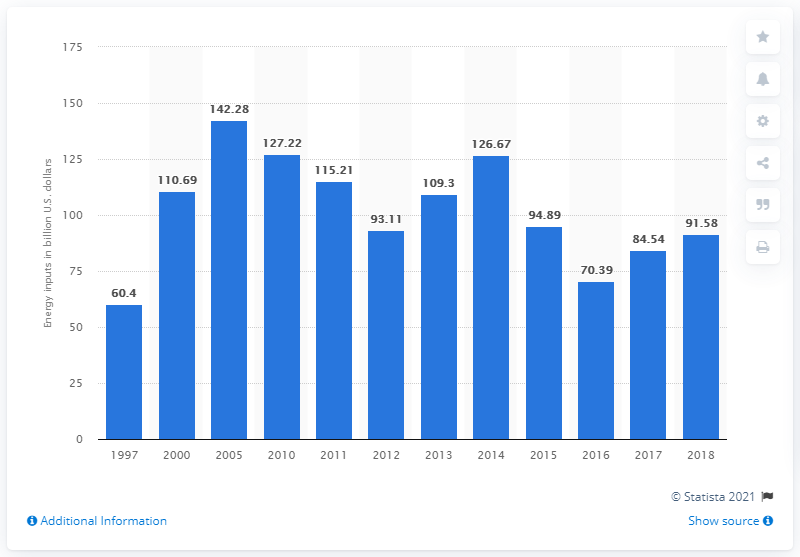Mention a couple of crucial points in this snapshot. In 2018, the utilities industry required an energy input cost of 91.58. The utilities industry has not experienced a significant change in energy inputs since 1997. 